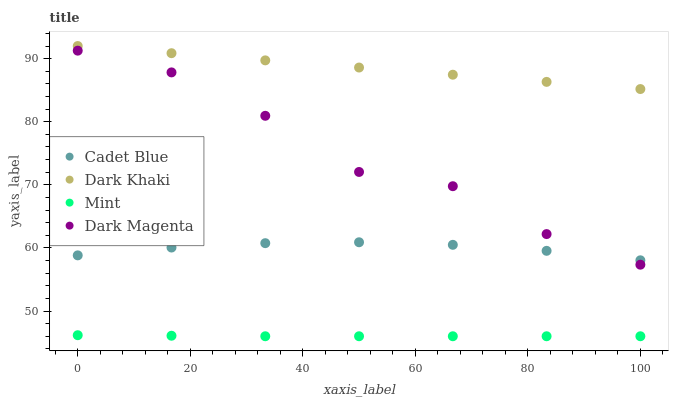Does Mint have the minimum area under the curve?
Answer yes or no. Yes. Does Dark Khaki have the maximum area under the curve?
Answer yes or no. Yes. Does Cadet Blue have the minimum area under the curve?
Answer yes or no. No. Does Cadet Blue have the maximum area under the curve?
Answer yes or no. No. Is Dark Khaki the smoothest?
Answer yes or no. Yes. Is Dark Magenta the roughest?
Answer yes or no. Yes. Is Cadet Blue the smoothest?
Answer yes or no. No. Is Cadet Blue the roughest?
Answer yes or no. No. Does Mint have the lowest value?
Answer yes or no. Yes. Does Cadet Blue have the lowest value?
Answer yes or no. No. Does Dark Khaki have the highest value?
Answer yes or no. Yes. Does Cadet Blue have the highest value?
Answer yes or no. No. Is Mint less than Cadet Blue?
Answer yes or no. Yes. Is Dark Magenta greater than Mint?
Answer yes or no. Yes. Does Cadet Blue intersect Dark Magenta?
Answer yes or no. Yes. Is Cadet Blue less than Dark Magenta?
Answer yes or no. No. Is Cadet Blue greater than Dark Magenta?
Answer yes or no. No. Does Mint intersect Cadet Blue?
Answer yes or no. No. 